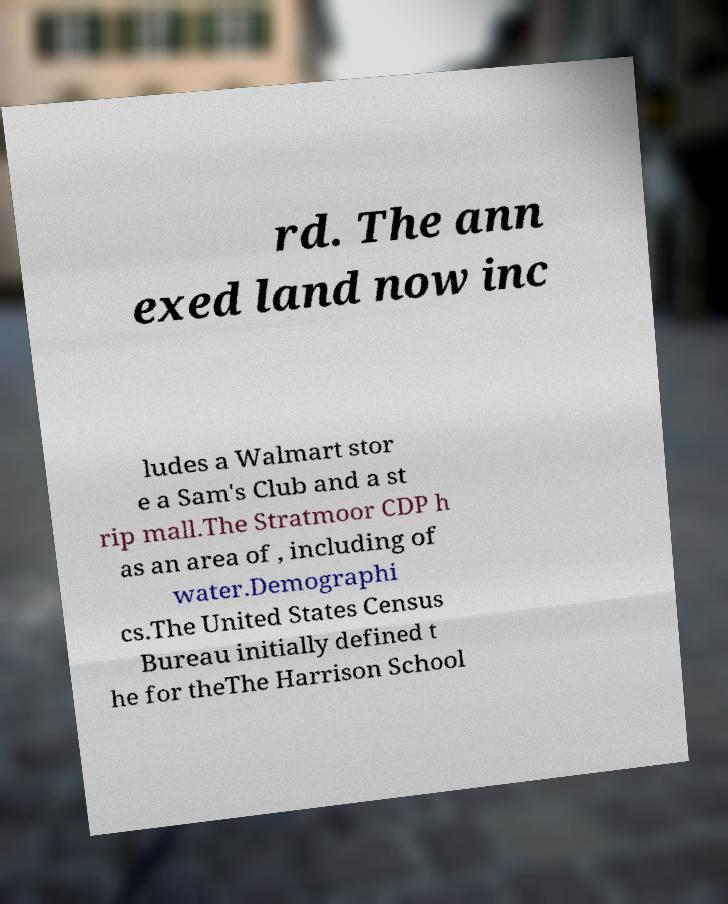Please identify and transcribe the text found in this image. rd. The ann exed land now inc ludes a Walmart stor e a Sam's Club and a st rip mall.The Stratmoor CDP h as an area of , including of water.Demographi cs.The United States Census Bureau initially defined t he for theThe Harrison School 